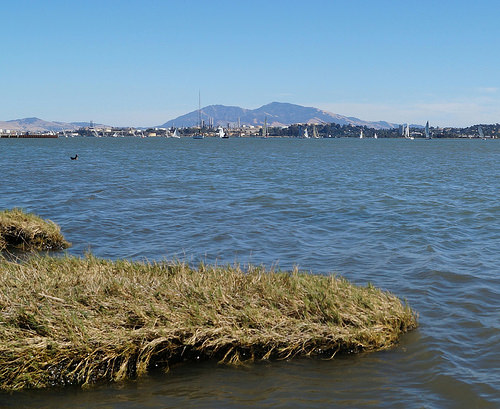<image>
Can you confirm if the grass is to the right of the water? No. The grass is not to the right of the water. The horizontal positioning shows a different relationship. 